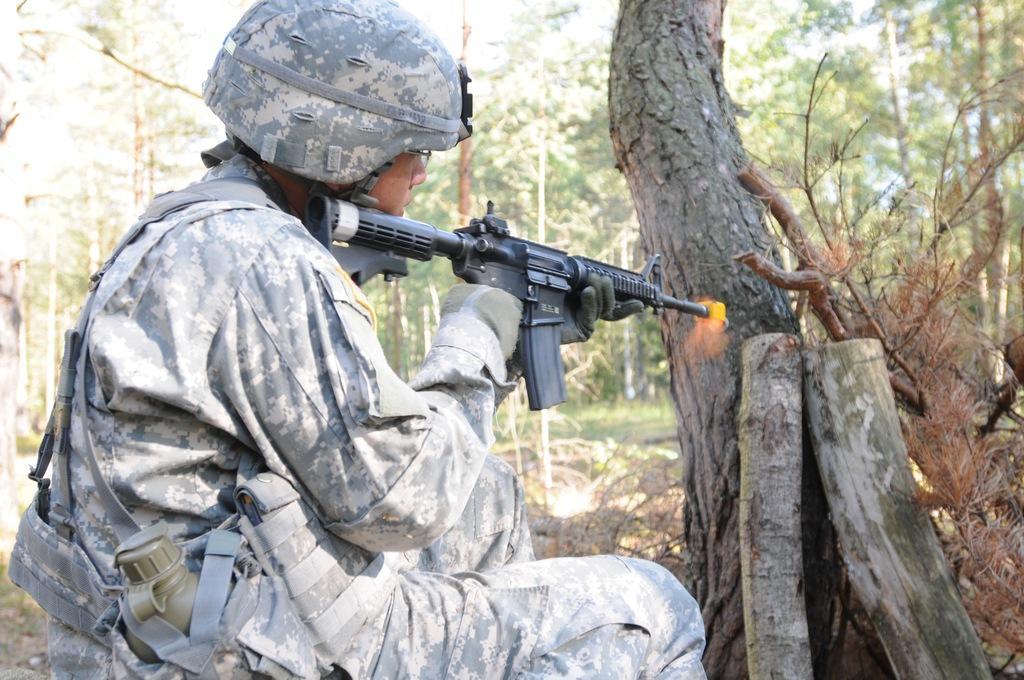Please provide a concise description of this image. In this picture I can observe a person on the left side. He is holding a black color gun in his hand. The person is wearing helmet on his head. In the background there are some trees. 